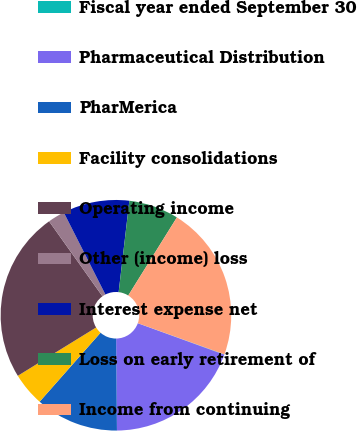<chart> <loc_0><loc_0><loc_500><loc_500><pie_chart><fcel>Fiscal year ended September 30<fcel>Pharmaceutical Distribution<fcel>PharMerica<fcel>Facility consolidations<fcel>Operating income<fcel>Other (income) loss<fcel>Interest expense net<fcel>Loss on early retirement of<fcel>Income from continuing<nl><fcel>0.05%<fcel>19.31%<fcel>11.65%<fcel>4.69%<fcel>23.95%<fcel>2.37%<fcel>9.33%<fcel>7.01%<fcel>21.63%<nl></chart> 